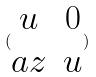<formula> <loc_0><loc_0><loc_500><loc_500>( \begin{matrix} u & 0 \\ a z & u \end{matrix} )</formula> 